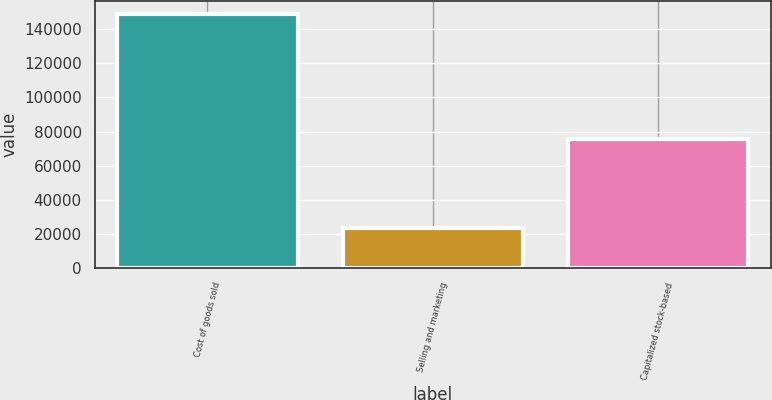Convert chart to OTSL. <chart><loc_0><loc_0><loc_500><loc_500><bar_chart><fcel>Cost of goods sold<fcel>Selling and marketing<fcel>Capitalized stock-based<nl><fcel>149075<fcel>23685<fcel>75725<nl></chart> 